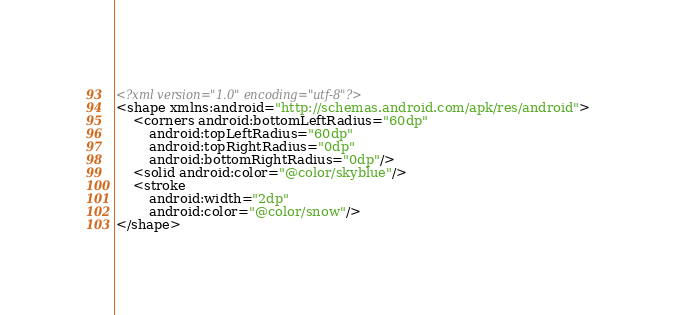Convert code to text. <code><loc_0><loc_0><loc_500><loc_500><_XML_><?xml version="1.0" encoding="utf-8"?>
<shape xmlns:android="http://schemas.android.com/apk/res/android">
    <corners android:bottomLeftRadius="60dp"
        android:topLeftRadius="60dp"
        android:topRightRadius="0dp"
        android:bottomRightRadius="0dp"/>
    <solid android:color="@color/skyblue"/>
    <stroke
        android:width="2dp"
        android:color="@color/snow"/>
</shape></code> 